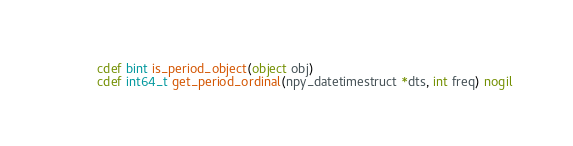Convert code to text. <code><loc_0><loc_0><loc_500><loc_500><_Cython_>

cdef bint is_period_object(object obj)
cdef int64_t get_period_ordinal(npy_datetimestruct *dts, int freq) nogil
</code> 